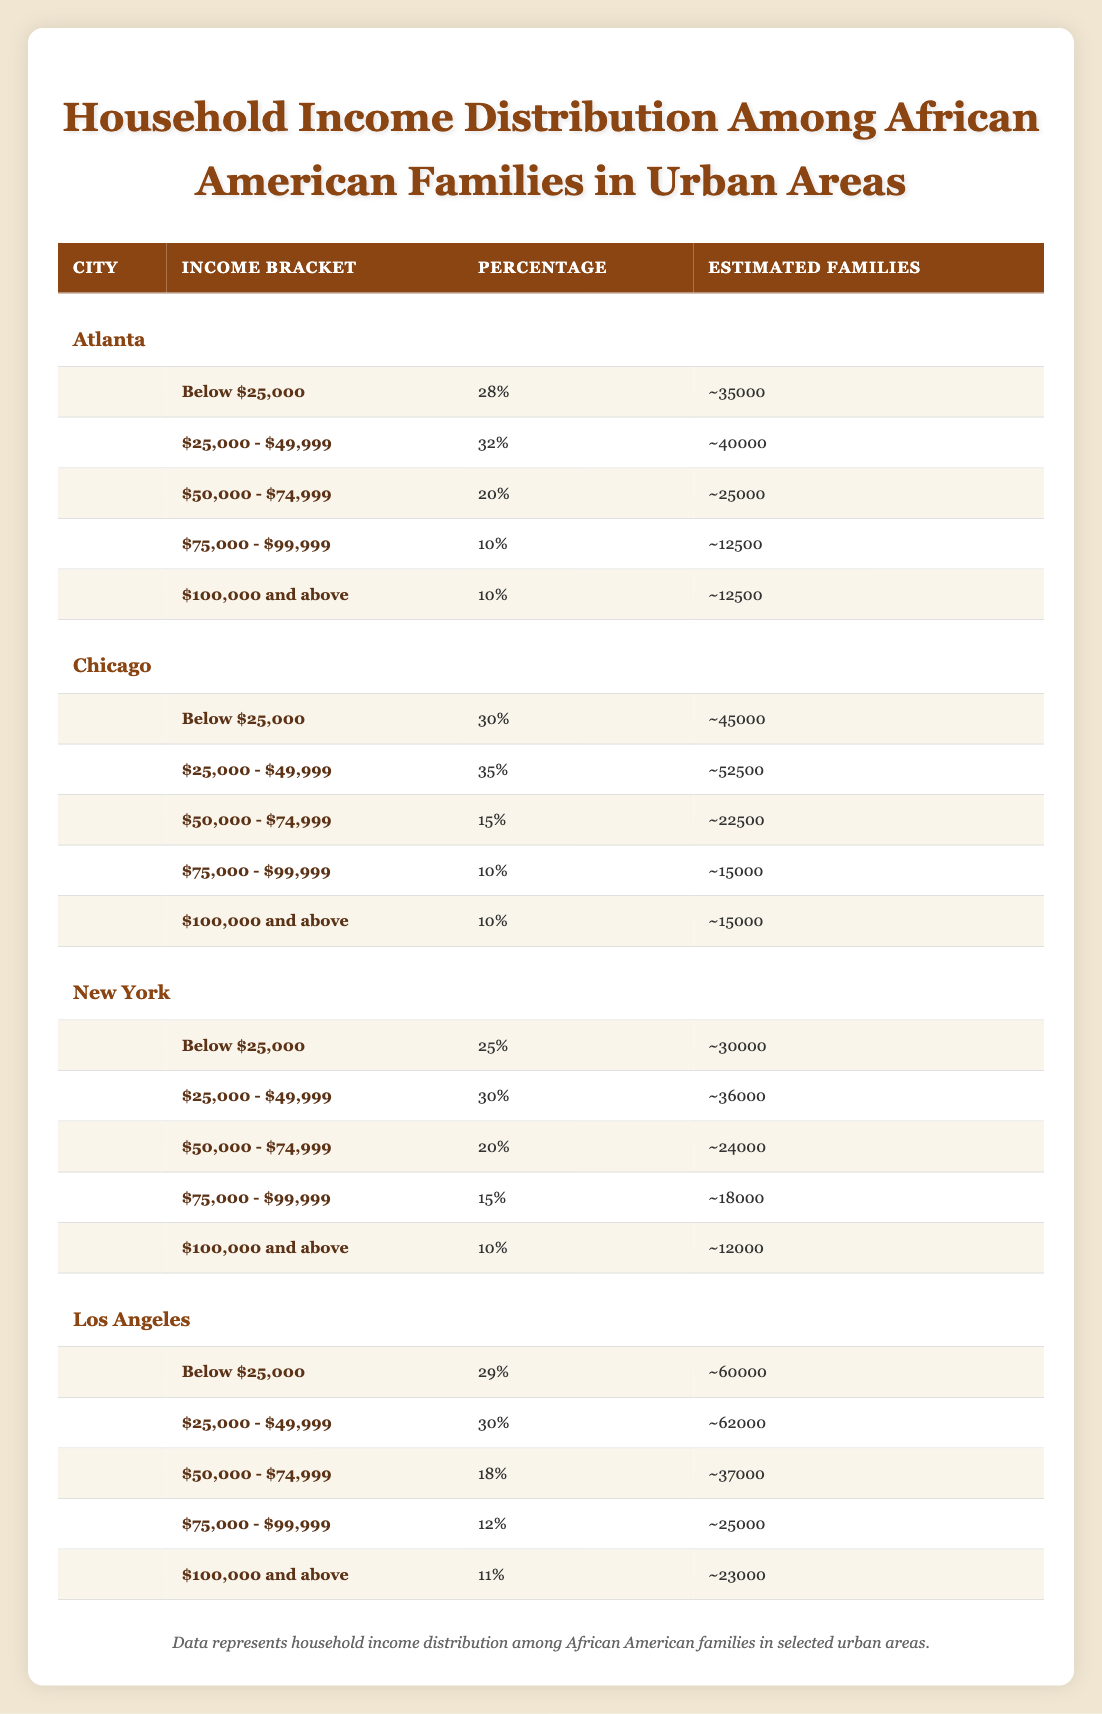What percentage of families in Atlanta earn below $25,000? The table shows that in Atlanta, 28% of families are in the income bracket classified as "Below $25,000."
Answer: 28% In which city do the most families earn between $25,000 and $49,999? By looking at the estimated families in the "$25,000 - $49,999" bracket, Atlanta has 40,000 families, while Chicago has 52,500 and Los Angeles has 62,000, meaning that Los Angeles has the most families in this income bracket.
Answer: Los Angeles What is the total percentage of families earning $75,000 or more in Chicago? In Chicago, the families earning $75,000 - $99,999 make up 10%, and those earning $100,000 and above also account for 10%. Adding these percentages together gives 10 + 10 = 20%.
Answer: 20% Is it true that more than 25% of families in New York earn below $25,000? In New York, 25% of families are in the "Below $25,000" income bracket, which does not exceed 25%, making the statement false.
Answer: No What city has the highest estimated number of families earning below $25,000, and how many families is that? From the table, Los Angeles has the highest estimated families in the "Below $25,000" income bracket at 60,000, compared to Atlanta's 35,000 and Chicago's 45,000.
Answer: Los Angeles; 60000 What is the average estimated number of families across all cities for the income bracket $50,000 - $74,999? For $50,000 - $74,999, the estimated families are: Atlanta (25,000), Chicago (22,500), New York (24,000), and Los Angeles (37,000). The average is calculated as (25,000 + 22,500 + 24,000 + 37,000) / 4 = 27,125.
Answer: 27125 Which income bracket in Chicago has the highest percentage of families? In Chicago, the income bracket with the highest percentage of families is "$25,000 - $49,999," which accounts for 35% of families.
Answer: $25,000 - $49,999 How many estimated families earn $100,000 and above in Los Angeles? The table indicates that Los Angeles has 23,000 families earning "$100,000 and above."
Answer: 23000 